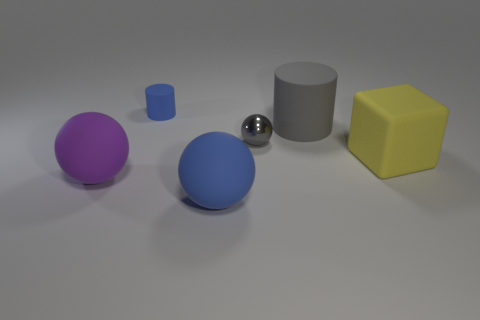Add 1 tiny blue objects. How many objects exist? 7 Subtract all cylinders. How many objects are left? 4 Add 1 metal spheres. How many metal spheres are left? 2 Add 3 large cylinders. How many large cylinders exist? 4 Subtract 1 blue balls. How many objects are left? 5 Subtract all gray objects. Subtract all green things. How many objects are left? 4 